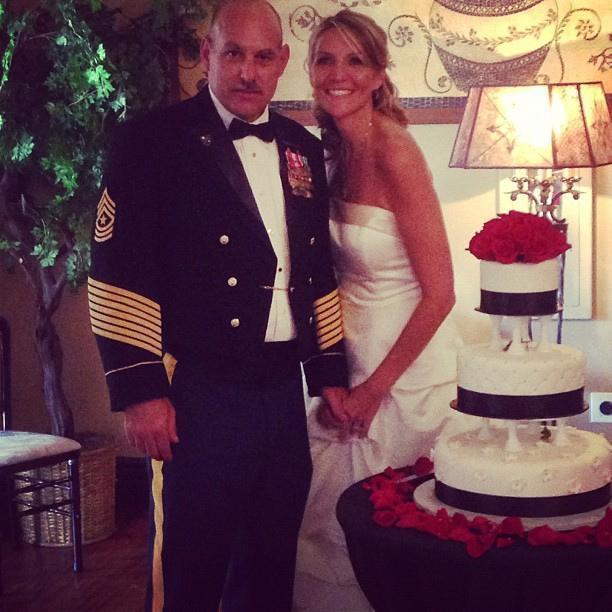How many buttons on the jacket?
Give a very brief answer. 3. How many people are in the picture?
Give a very brief answer. 2. How many cakes can you see?
Give a very brief answer. 3. How many toothbrushes are in this picture?
Give a very brief answer. 0. 